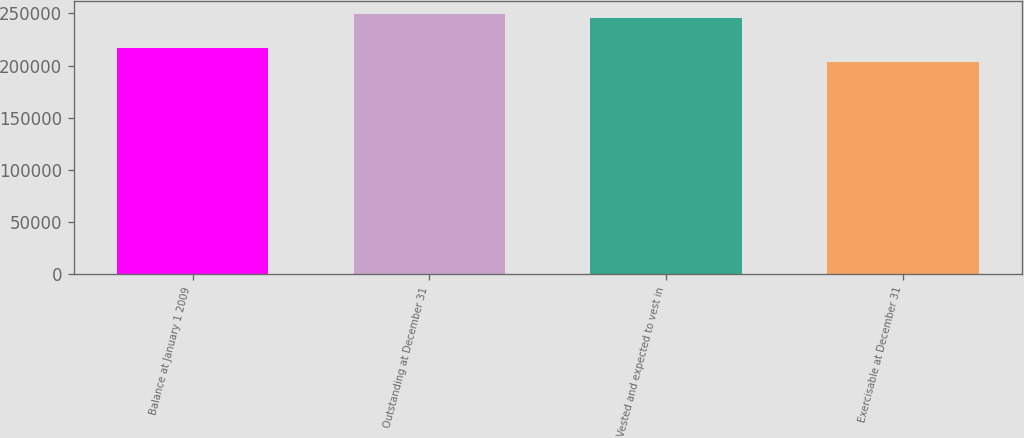Convert chart. <chart><loc_0><loc_0><loc_500><loc_500><bar_chart><fcel>Balance at January 1 2009<fcel>Outstanding at December 31<fcel>Vested and expected to vest in<fcel>Exercisable at December 31<nl><fcel>216580<fcel>249867<fcel>245340<fcel>203015<nl></chart> 